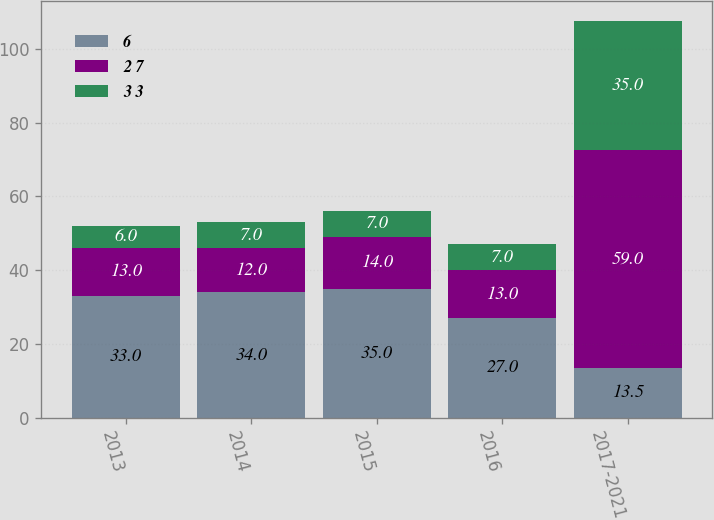<chart> <loc_0><loc_0><loc_500><loc_500><stacked_bar_chart><ecel><fcel>2013<fcel>2014<fcel>2015<fcel>2016<fcel>2017-2021<nl><fcel>6<fcel>33<fcel>34<fcel>35<fcel>27<fcel>13.5<nl><fcel>2 7<fcel>13<fcel>12<fcel>14<fcel>13<fcel>59<nl><fcel>3 3<fcel>6<fcel>7<fcel>7<fcel>7<fcel>35<nl></chart> 